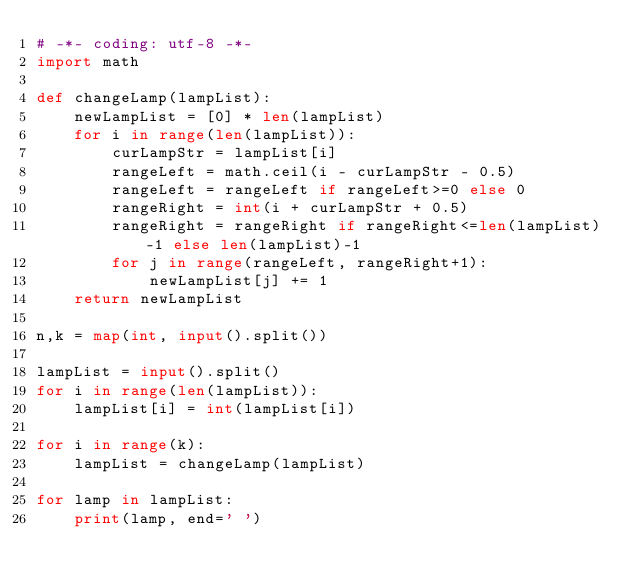<code> <loc_0><loc_0><loc_500><loc_500><_Python_># -*- coding: utf-8 -*-
import math

def changeLamp(lampList):
    newLampList = [0] * len(lampList)
    for i in range(len(lampList)):
        curLampStr = lampList[i]
        rangeLeft = math.ceil(i - curLampStr - 0.5)
        rangeLeft = rangeLeft if rangeLeft>=0 else 0
        rangeRight = int(i + curLampStr + 0.5)
        rangeRight = rangeRight if rangeRight<=len(lampList)-1 else len(lampList)-1
        for j in range(rangeLeft, rangeRight+1):
            newLampList[j] += 1
    return newLampList

n,k = map(int, input().split())

lampList = input().split()
for i in range(len(lampList)):
    lampList[i] = int(lampList[i])

for i in range(k):
    lampList = changeLamp(lampList)

for lamp in lampList:
    print(lamp, end=' ')</code> 